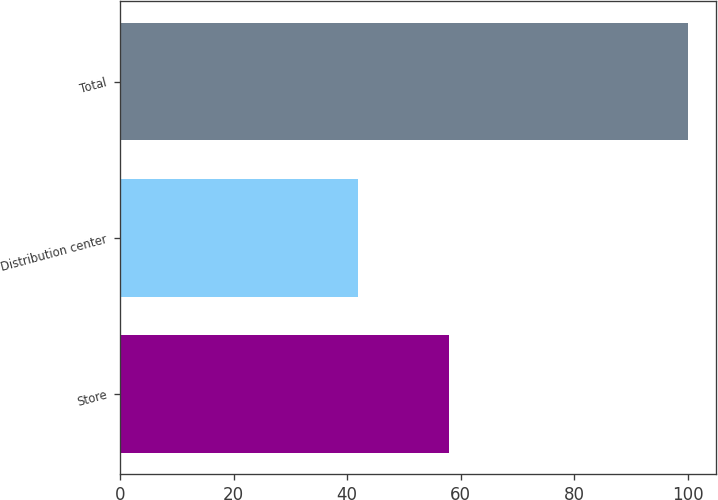Convert chart. <chart><loc_0><loc_0><loc_500><loc_500><bar_chart><fcel>Store<fcel>Distribution center<fcel>Total<nl><fcel>58<fcel>42<fcel>100<nl></chart> 